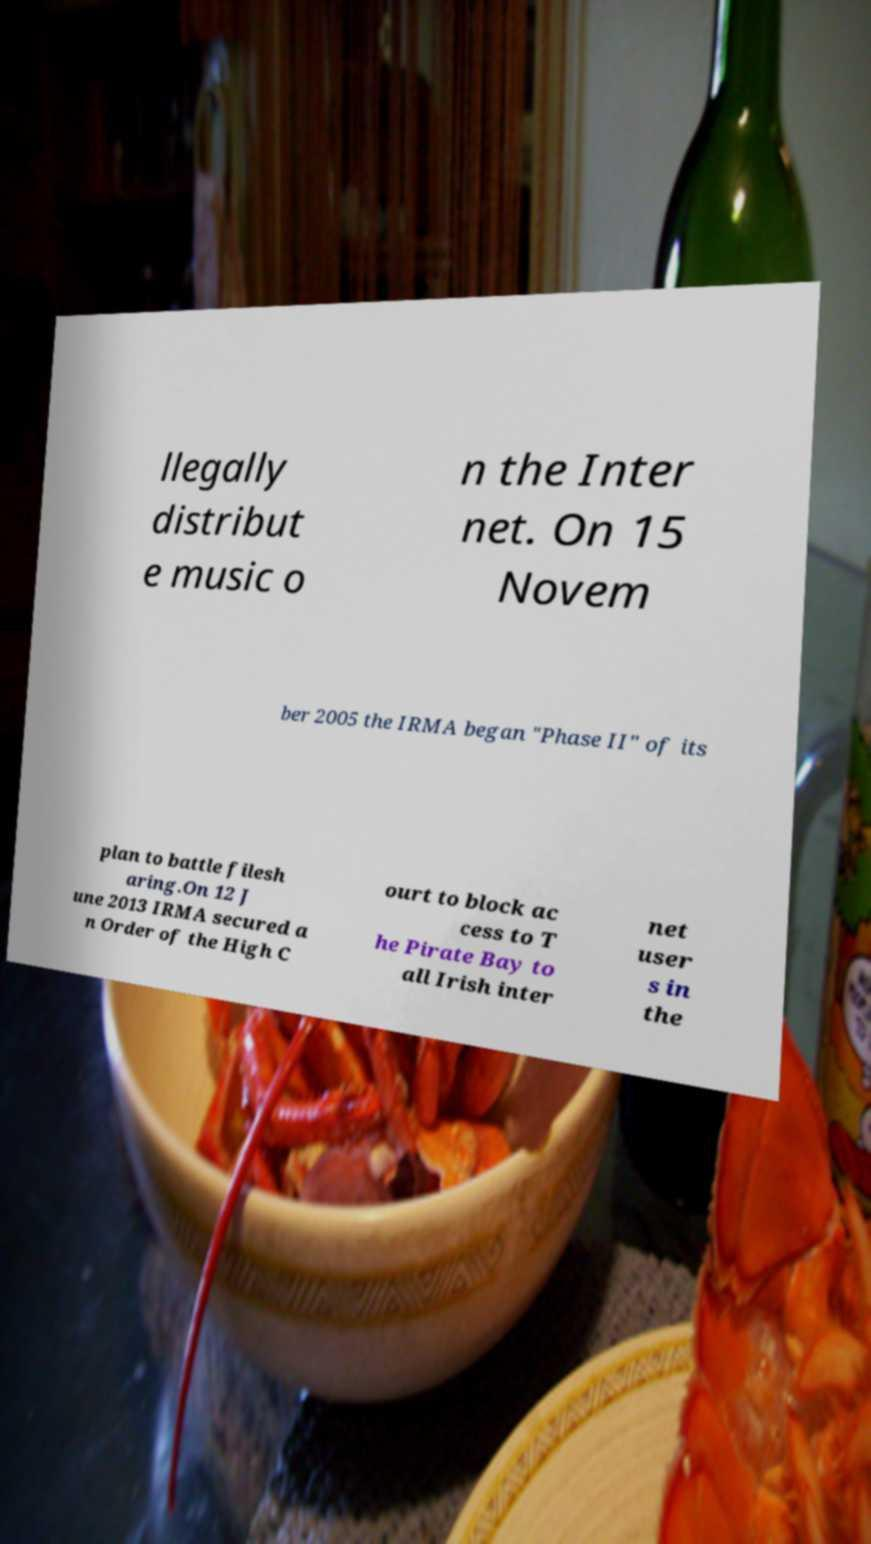There's text embedded in this image that I need extracted. Can you transcribe it verbatim? llegally distribut e music o n the Inter net. On 15 Novem ber 2005 the IRMA began "Phase II" of its plan to battle filesh aring.On 12 J une 2013 IRMA secured a n Order of the High C ourt to block ac cess to T he Pirate Bay to all Irish inter net user s in the 